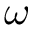<formula> <loc_0><loc_0><loc_500><loc_500>\omega</formula> 